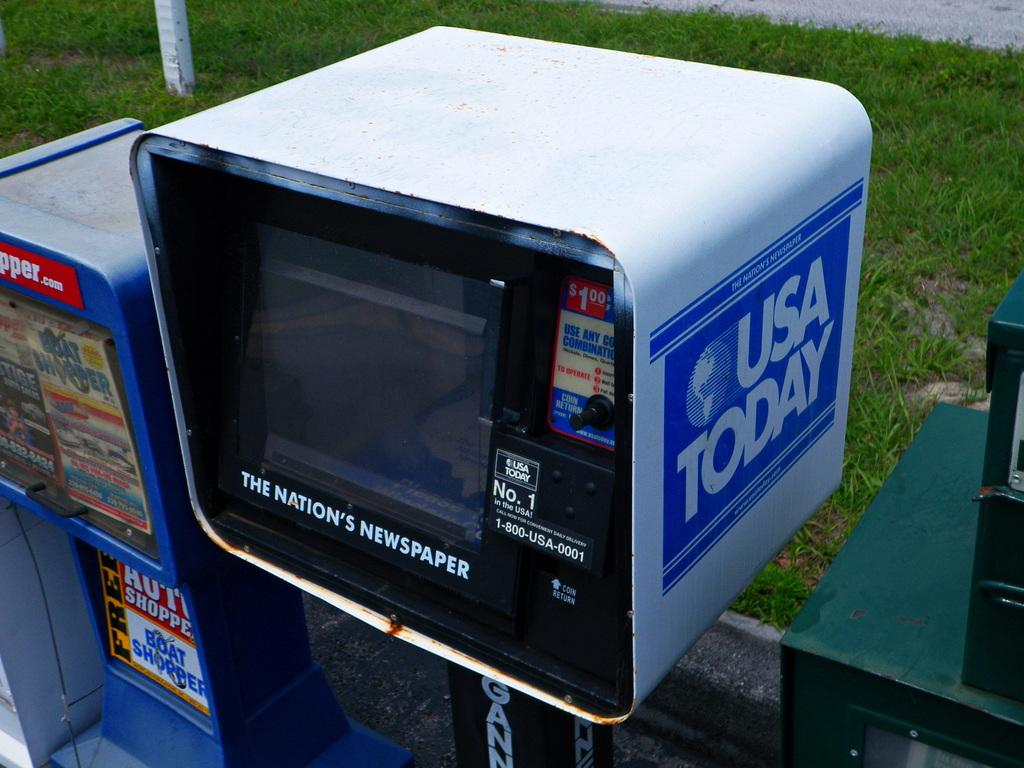<image>
Relay a brief, clear account of the picture shown. A row of USA Today newspaper vending machines on a sidewalk. 